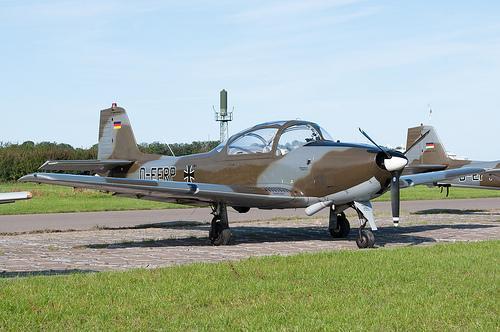How many planes are in the picture?
Give a very brief answer. 2. 